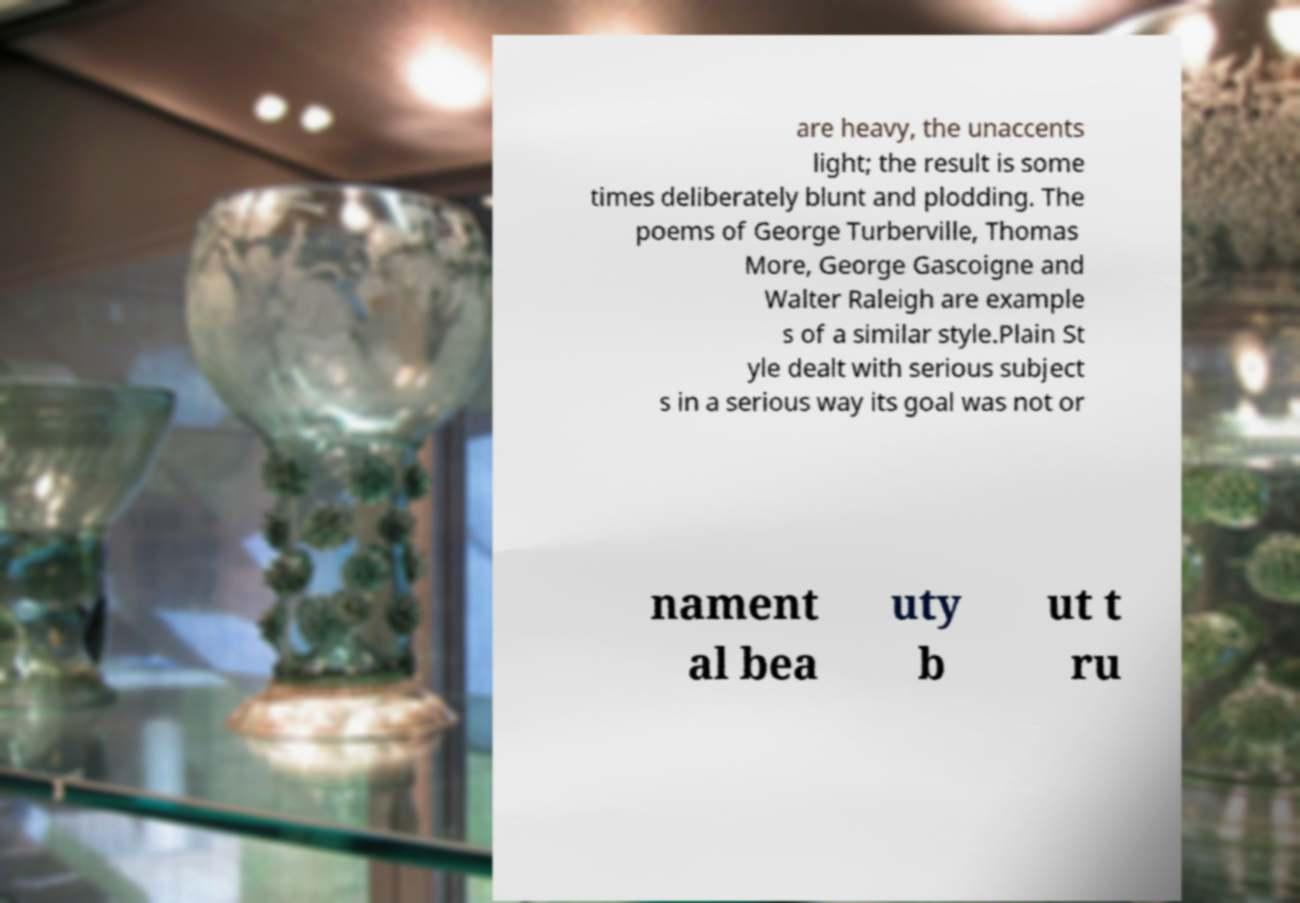Could you assist in decoding the text presented in this image and type it out clearly? are heavy, the unaccents light; the result is some times deliberately blunt and plodding. The poems of George Turberville, Thomas More, George Gascoigne and Walter Raleigh are example s of a similar style.Plain St yle dealt with serious subject s in a serious way its goal was not or nament al bea uty b ut t ru 